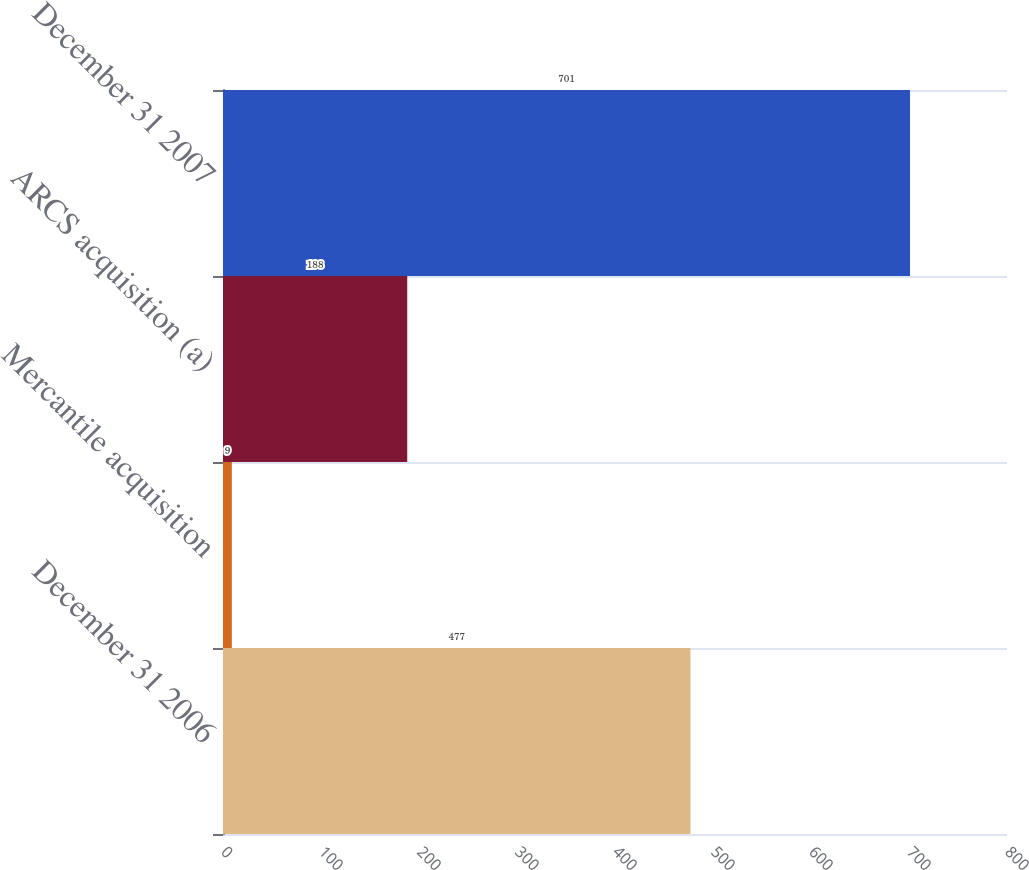Convert chart to OTSL. <chart><loc_0><loc_0><loc_500><loc_500><bar_chart><fcel>December 31 2006<fcel>Mercantile acquisition<fcel>ARCS acquisition (a)<fcel>December 31 2007<nl><fcel>477<fcel>9<fcel>188<fcel>701<nl></chart> 